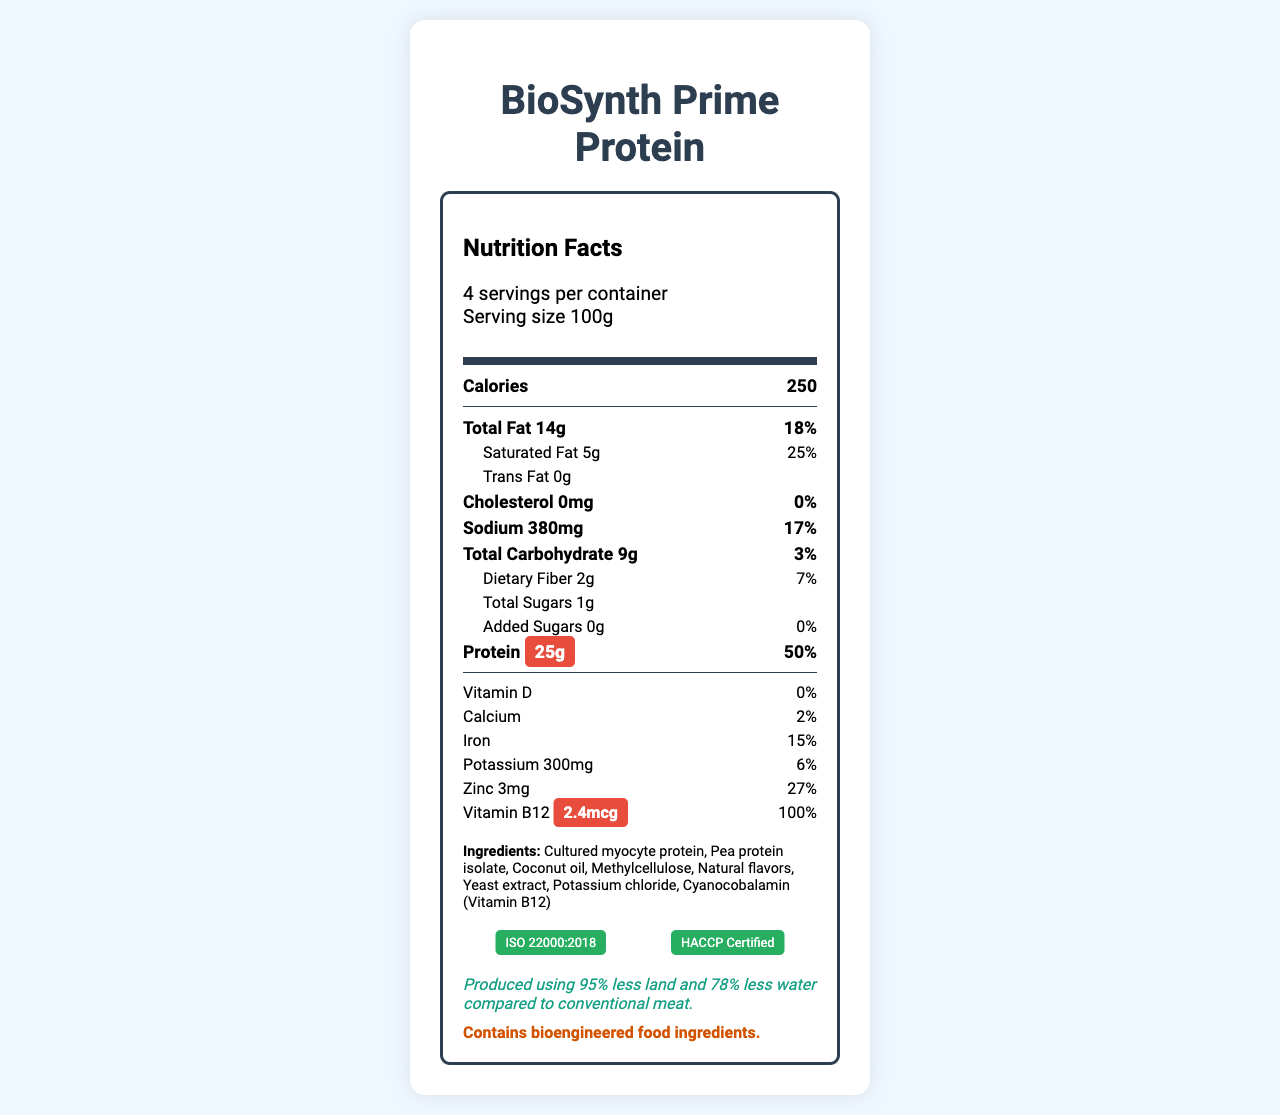what is the serving size? The document states that the serving size is 100g.
Answer: 100g how many servings are there per container? The document specifies that there are 4 servings per container.
Answer: 4 what percentage of daily value does the protein provide? The document lists the daily value of protein at 50%.
Answer: 50% what ingredient provides vitamin B12? The ingredients list includes "Cyanocobalamin (Vitamin B12)".
Answer: Cyanocobalamin how many calories are there in one serving? The document states that each serving contains 250 calories.
Answer: 250 which of the following vitamins is present in BioSynth Prime Protein? A. Vitamin D B. Vitamin B12 C. Vitamin C D. Vitamin K The document indicates that BioSynth Prime Protein contains Vitamin B12.
Answer: B how much sodium is in one serving of BioSynth Prime Protein? The document specifies that the sodium content is 380mg per serving.
Answer: 380mg which certification labels are included in the document? A. ISO 9001:2015 B. ISO 22000:2018 C. HACCP Certified D. Fair Trade Certified The document includes ISO 22000:2018 and HACCP Certified labels under lab certifications.
Answer: B, C is there any cholesterol in BioSynth Prime Protein? The document states that the cholesterol amount is 0mg, which translates to 0%.
Answer: No summarize the main nutritional attributes of BioSynth Prime Protein. The document highlights key nutritional facts, focusing on protein and vitamin B12, emphasizing its health benefits compared with traditional meat.
Answer: BioSynth Prime Protein is a lab-grown meat substitute that provides 250 calories per 100g serving. It is rich in protein (25g, 50% daily value) and Vitamin B12 (2.4mcg, 100% daily value). It is low in cholesterol (0mg) and trans fat (0g), but contains some saturated fat (5g) and sodium (380mg). what is the shelf life of BioSynth Prime Protein? The document does not provide any information regarding the shelf life of BioSynth Prime Protein.
Answer: Cannot be determined 